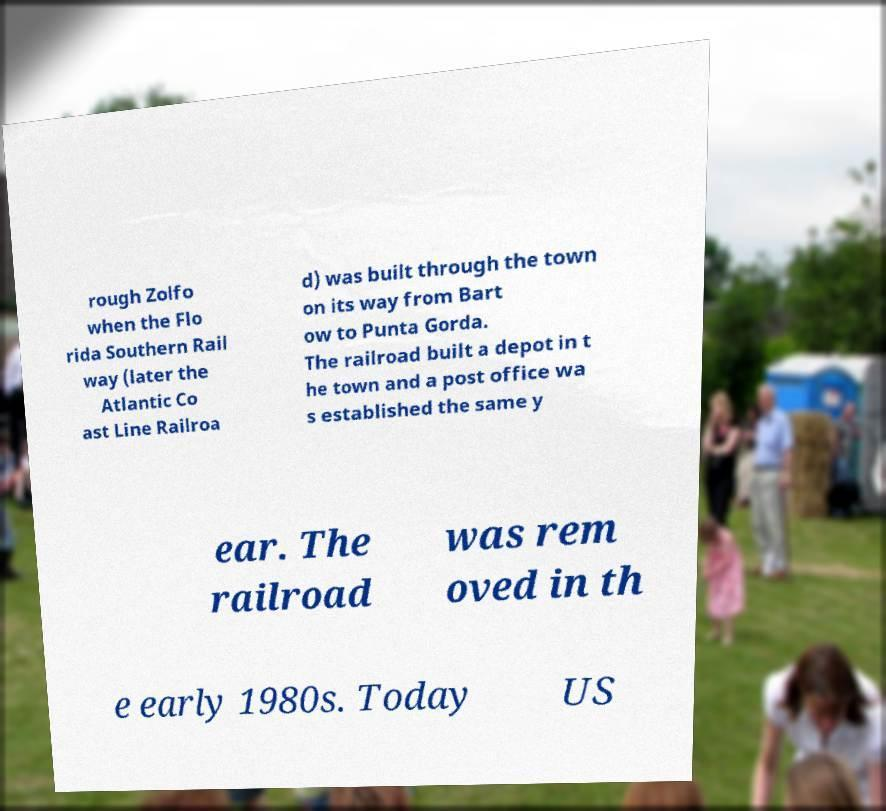Could you assist in decoding the text presented in this image and type it out clearly? rough Zolfo when the Flo rida Southern Rail way (later the Atlantic Co ast Line Railroa d) was built through the town on its way from Bart ow to Punta Gorda. The railroad built a depot in t he town and a post office wa s established the same y ear. The railroad was rem oved in th e early 1980s. Today US 